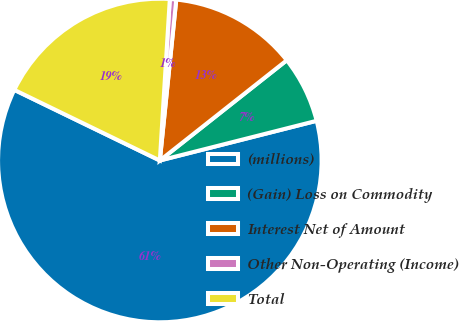Convert chart. <chart><loc_0><loc_0><loc_500><loc_500><pie_chart><fcel>(millions)<fcel>(Gain) Loss on Commodity<fcel>Interest Net of Amount<fcel>Other Non-Operating (Income)<fcel>Total<nl><fcel>61.14%<fcel>6.69%<fcel>12.74%<fcel>0.64%<fcel>18.79%<nl></chart> 